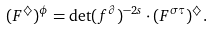<formula> <loc_0><loc_0><loc_500><loc_500>( F ^ { \diamondsuit } ) ^ { \phi } = \det ( f ^ { \partial } ) ^ { - 2 s } \cdot ( F ^ { \sigma \tau } ) ^ { \diamondsuit } .</formula> 